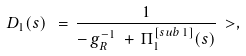<formula> <loc_0><loc_0><loc_500><loc_500>D _ { 1 } ( s ) \ = \ & \frac { 1 } { - \, g _ { R } ^ { - 1 } \ + \ \Pi ^ { [ s u b \, 1 ] } _ { 1 } ( s ) } \ > ,</formula> 